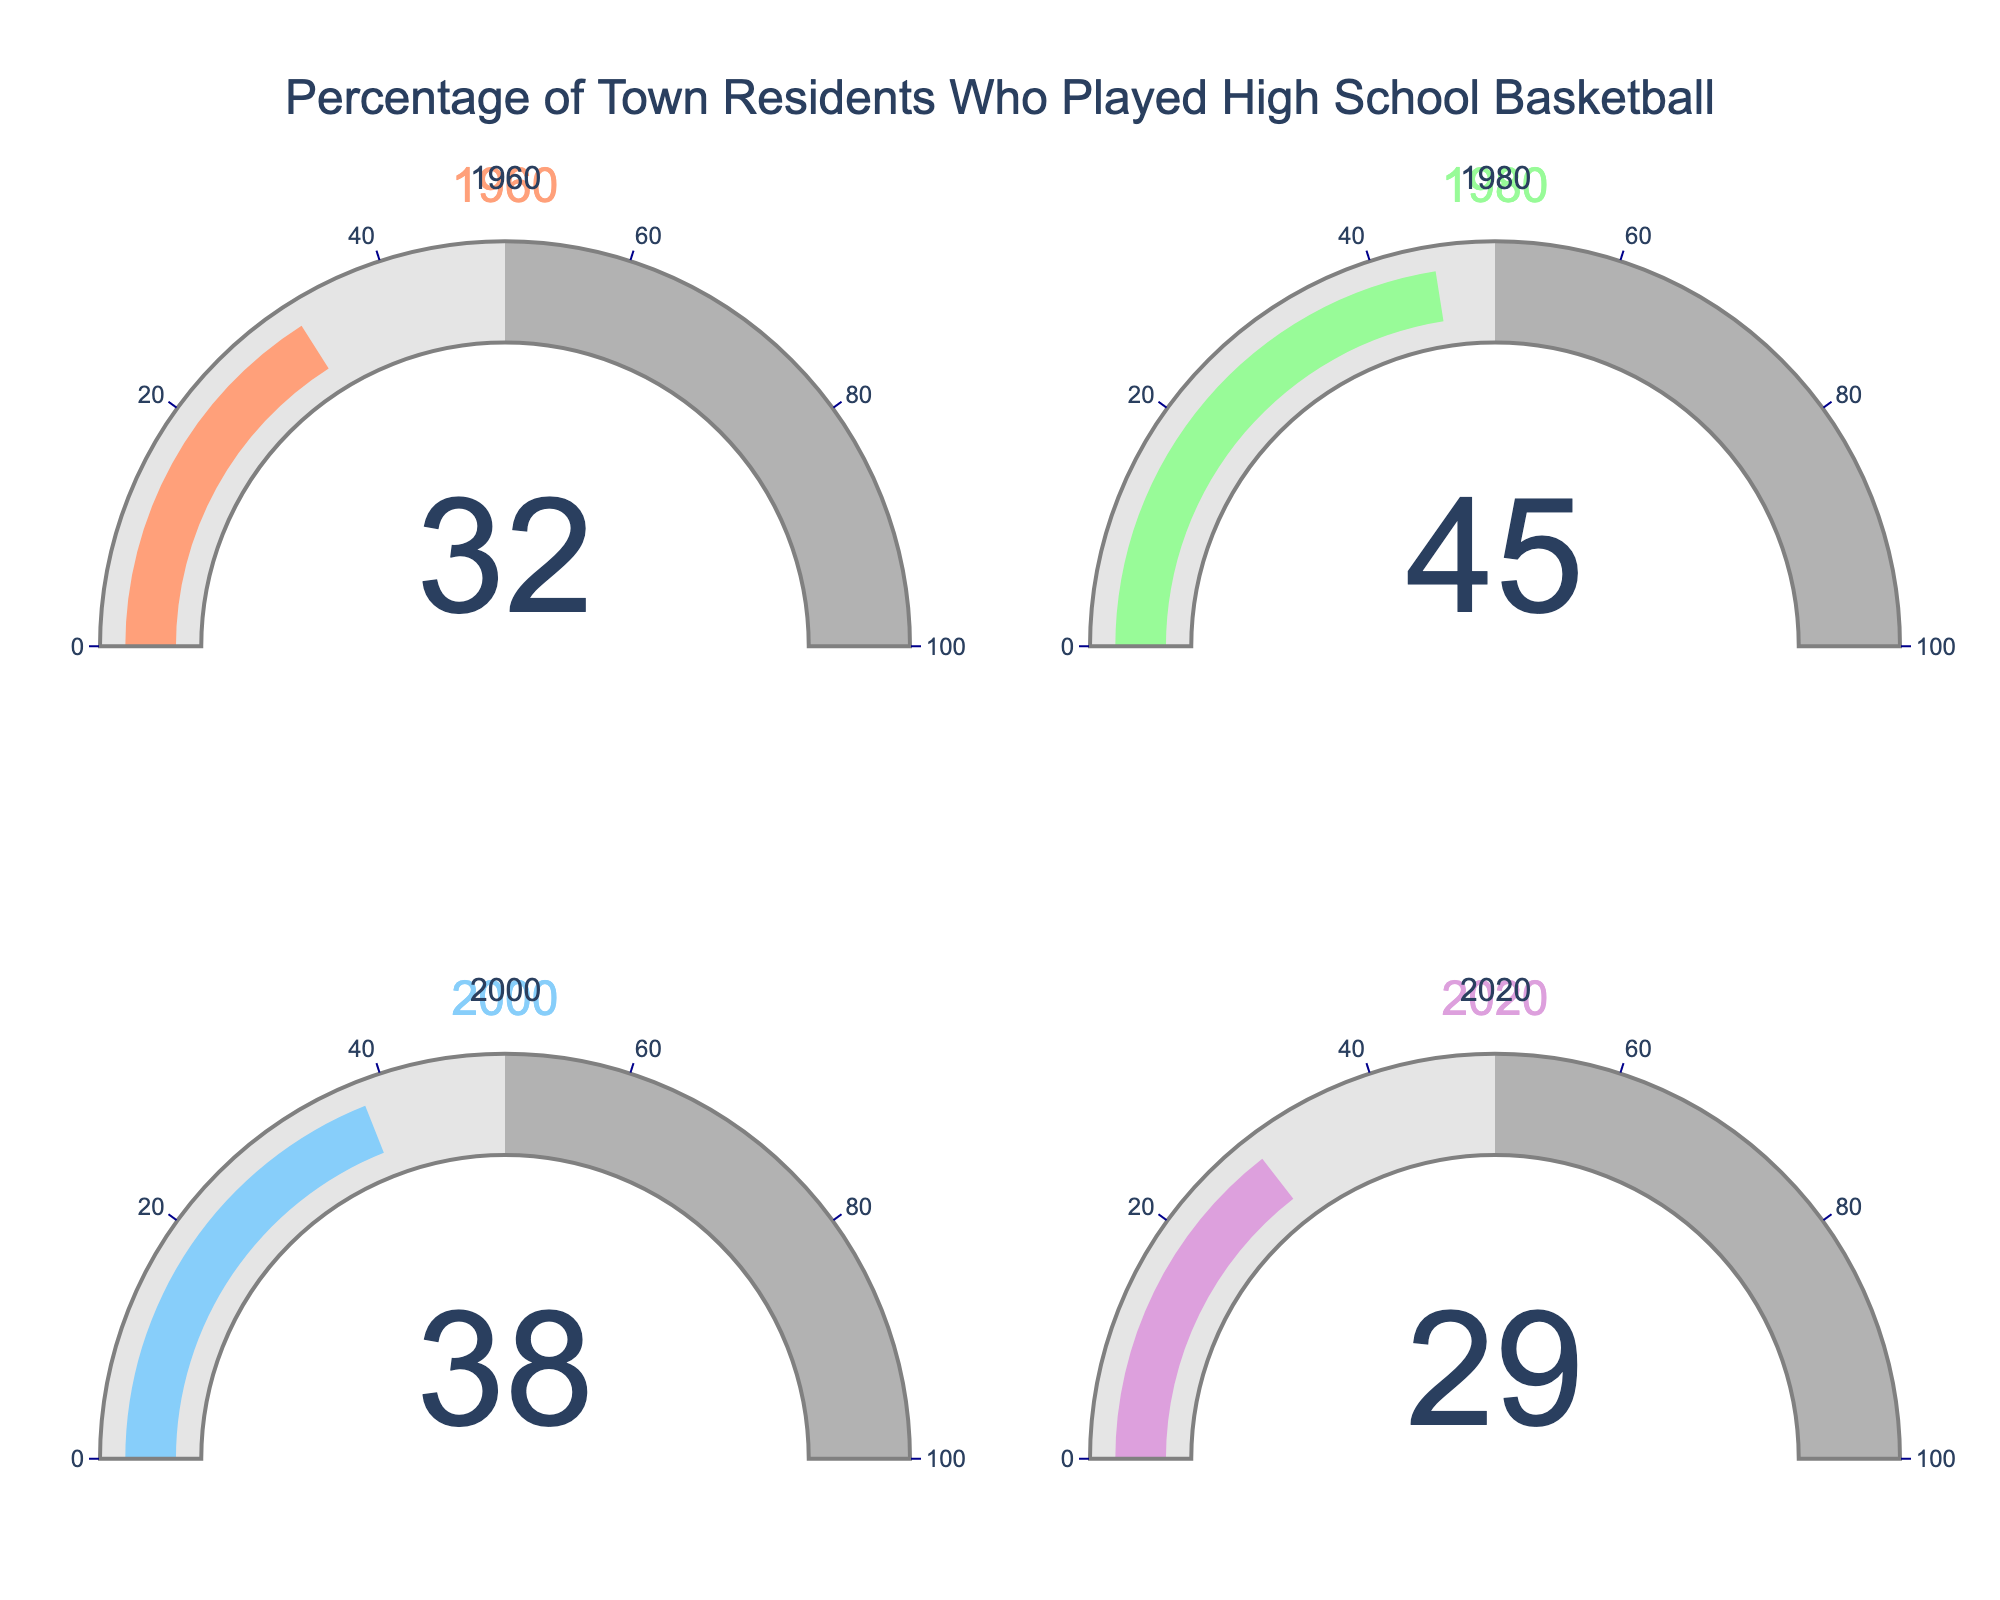Which year had the highest percentage of town residents who played high school basketball? Look at each gauge to identify the year with the highest percentage. In 1980, the percentage is 45%, which is higher than 1960 (32%), 2000 (38%), and 2020 (29%).
Answer: 1980 What was the percentage of residents who played high school basketball in 1960? Look at the gauge for 1960 to find the percentage. The gauge shows a value of 32%.
Answer: 32% What is the average percentage of residents who played high school basketball over the given years? Sum up the percentages for each year: 32 + 45 + 38 + 29 = 144. Then divide by the number of years: 144 / 4 = 36.
Answer: 36 Which year saw the largest decrease in percentage of town residents who played high school basketball from the previous measurement? Compare decreases between consecutive years: From 1980 to 2000 (45% to 38%) is 7%, and from 2000 to 2020 (38% to 29%) is 9%. The largest decrease is from 2000 to 2020.
Answer: 2000 to 2020 What is the percentage difference between the year with the highest percentage and the year with the lowest percentage? Identify the highest percentage (1980, 45%) and the lowest percentage (2020, 29%). Calculate the difference: 45% - 29% = 16%.
Answer: 16% How much did the percentage of residents who played high school basketball change from 1960 to 1980? Look at the values for 1960 (32%) and 1980 (45%). Calculate the difference: 45% - 32% = 13%.
Answer: 13% Did the percentage of residents who played high school basketball ever fall below 30%? Look at the gauges for each year. Only 2020 shows a percentage below 30%, specifically 29%.
Answer: Yes Which two consecutive years had the smallest change in percentage of town residents who played high school basketball? Compare the changes between consecutive years: From 1960 to 1980 (32% to 45%) is 13%, 1980 to 2000 (45% to 38%) is 7%, and 2000 to 2020 (38% to 29%) is 9%. The smallest change is between 1980 and 2000.
Answer: 1980 to 2000 